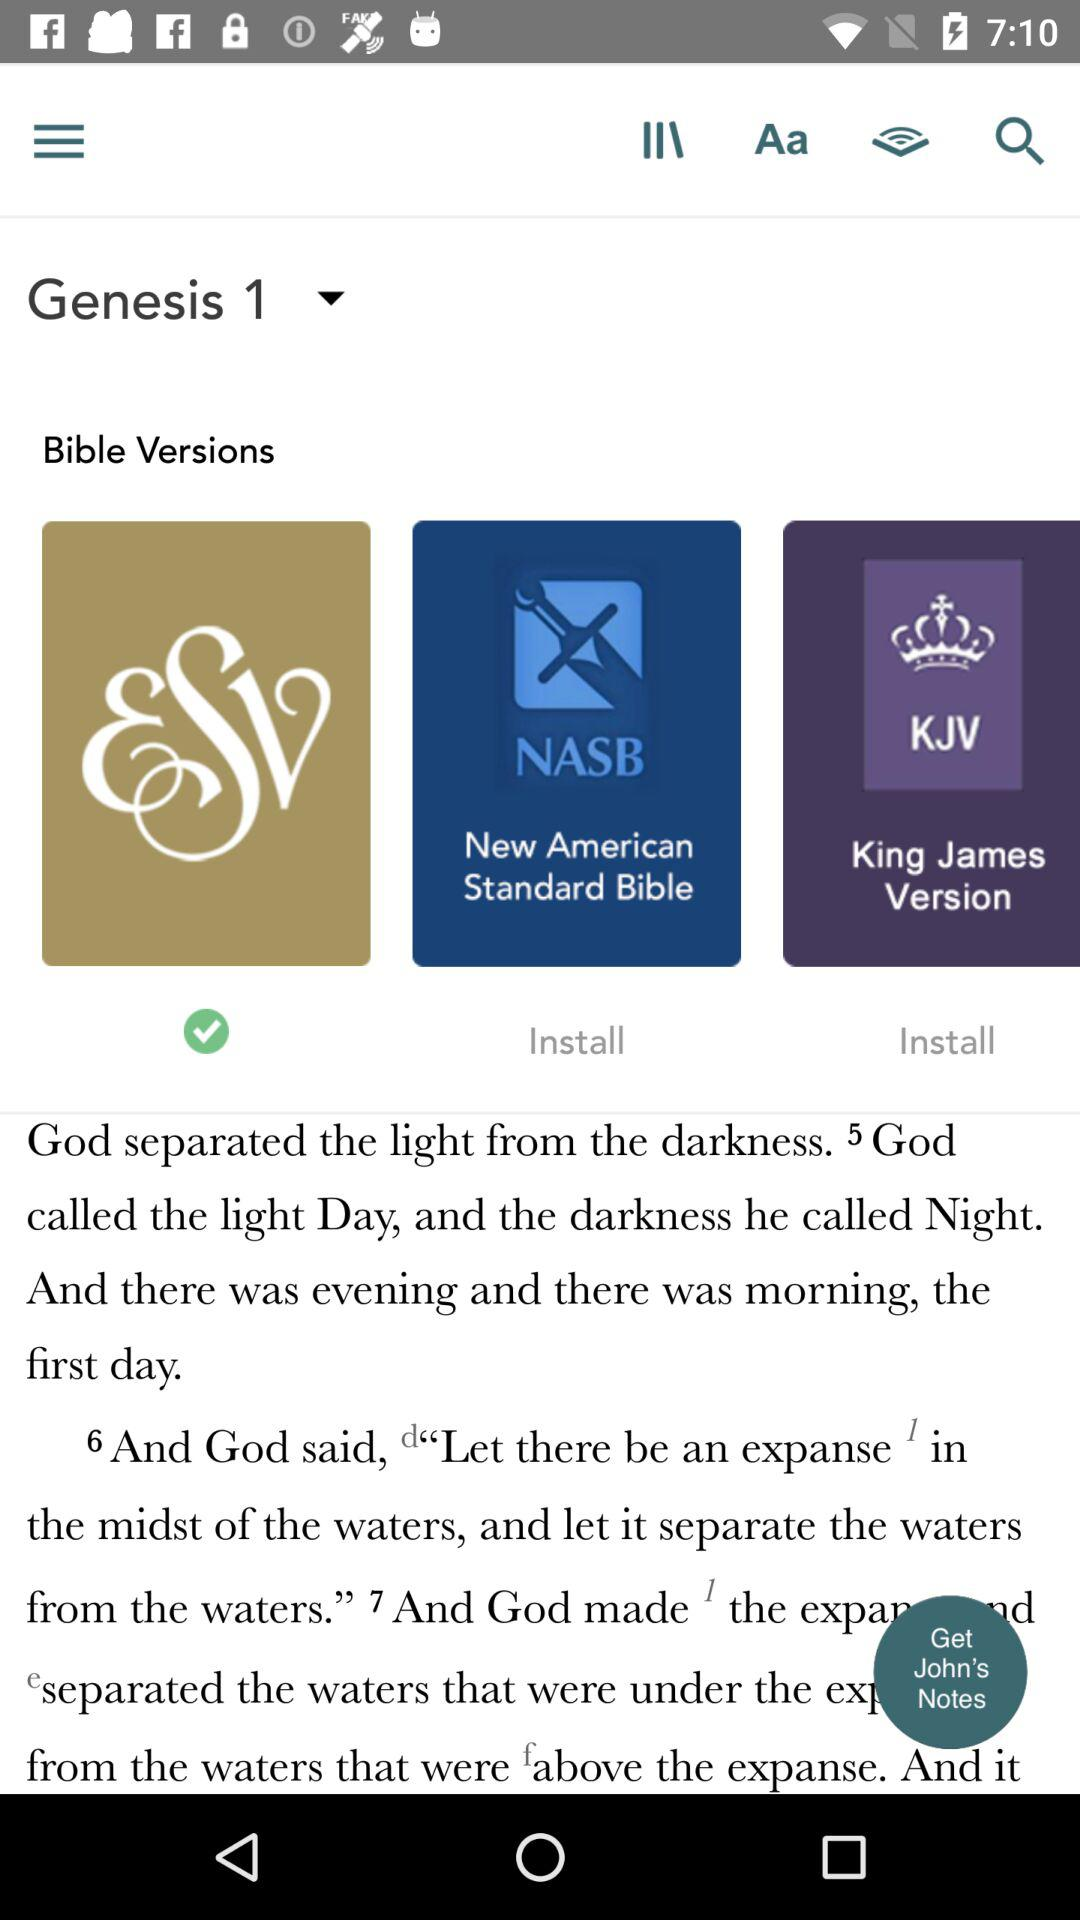How many Bible versions are available?
Answer the question using a single word or phrase. 3 